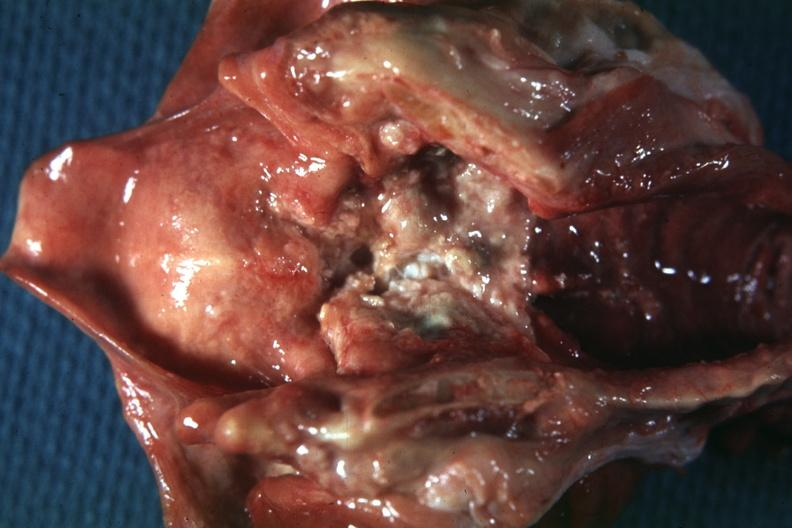s adenosis and ischemia present?
Answer the question using a single word or phrase. No 